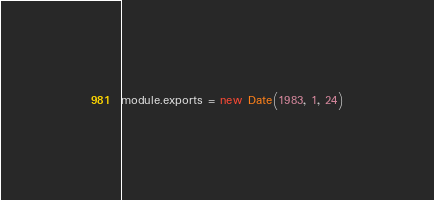Convert code to text. <code><loc_0><loc_0><loc_500><loc_500><_JavaScript_>module.exports = new Date(1983, 1, 24)
</code> 